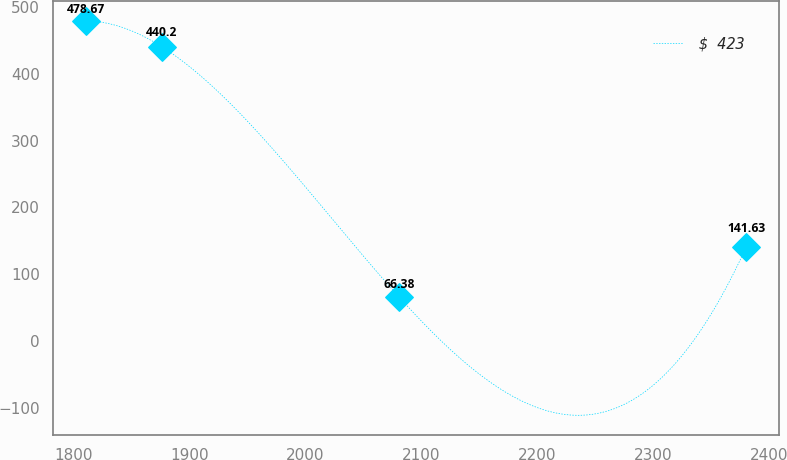<chart> <loc_0><loc_0><loc_500><loc_500><line_chart><ecel><fcel>$ 423<nl><fcel>1810.75<fcel>478.67<nl><fcel>1876.05<fcel>440.2<nl><fcel>2080.65<fcel>66.38<nl><fcel>2380.48<fcel>141.63<nl></chart> 